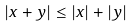<formula> <loc_0><loc_0><loc_500><loc_500>| x + y | \leq | x | + | y |</formula> 